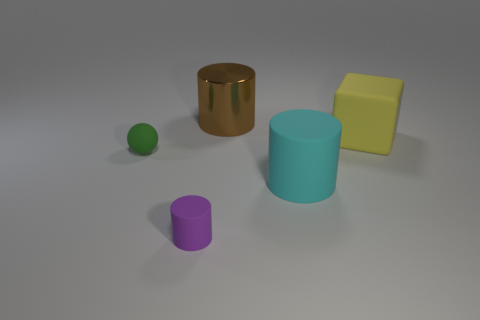Subtract all small purple matte cylinders. How many cylinders are left? 2 Add 2 large matte cylinders. How many objects exist? 7 Subtract all brown cylinders. How many cylinders are left? 2 Subtract all blocks. How many objects are left? 4 Subtract all big cylinders. Subtract all large brown objects. How many objects are left? 2 Add 4 large cyan cylinders. How many large cyan cylinders are left? 5 Add 2 yellow blocks. How many yellow blocks exist? 3 Subtract 0 red blocks. How many objects are left? 5 Subtract all brown cylinders. Subtract all red blocks. How many cylinders are left? 2 